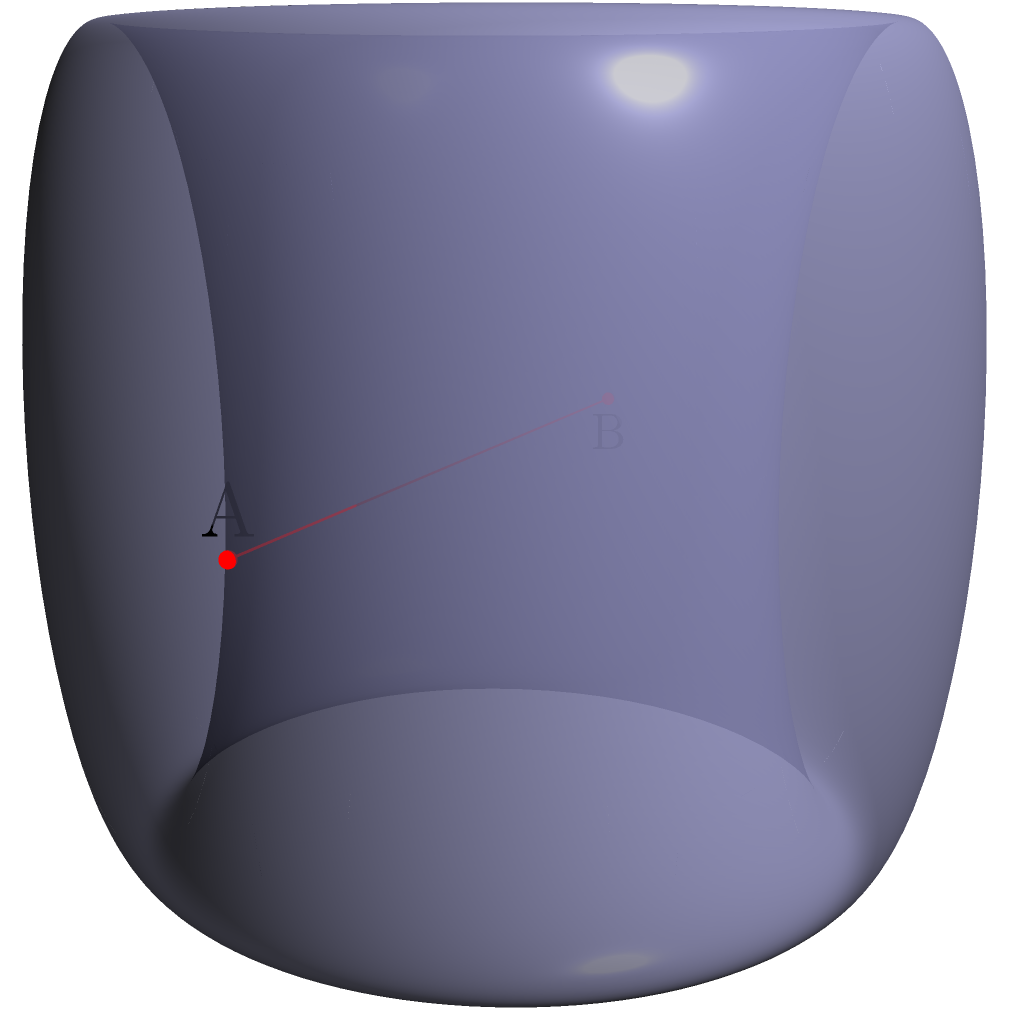In a toroidal network topology representing interconnected data centers, two centers A and B are located as shown on the surface. If the major radius of the torus is 2 units and the minor radius is 0.5 units, what is the shortest distance between data centers A and B along the surface of the torus? To solve this problem, we need to understand the geometry of a torus and how to measure distances on its surface. Let's approach this step-by-step:

1) The torus is defined by two radii:
   - Major radius (R) = 2 units (distance from the center of the tube to the center of the torus)
   - Minor radius (r) = 0.5 units (radius of the tube)

2) On a torus, the shortest path between two points is not always a straight line through space, but rather the shortest path along the surface.

3) The position of points on a torus can be described using two angles:
   - $\theta$ (theta): angle around the major circle (0 to 2π)
   - $\phi$ (phi): angle around the minor circle (0 to 2π)

4) In this case, point A is at (θ,φ) = (0,0) and point B is at (π,π).

5) The distance along the surface of the torus can be calculated using the formula:

   $$d = \sqrt{(R\Delta\theta)^2 + (r\Delta\phi)^2}$$

   Where Δθ and Δφ are the differences in the respective angles.

6) Here, Δθ = π and Δφ = π

7) Plugging in the values:

   $$d = \sqrt{(2\pi)^2 + (0.5\pi)^2}$$

8) Simplifying:

   $$d = \sqrt{4\pi^2 + 0.25\pi^2} = \sqrt{4.25\pi^2} = \pi\sqrt{4.25}$$

9) This simplifies to approximately 6.52 units.

Thus, the shortest distance between data centers A and B along the surface of the torus is $\pi\sqrt{4.25}$ units.
Answer: $\pi\sqrt{4.25}$ units 